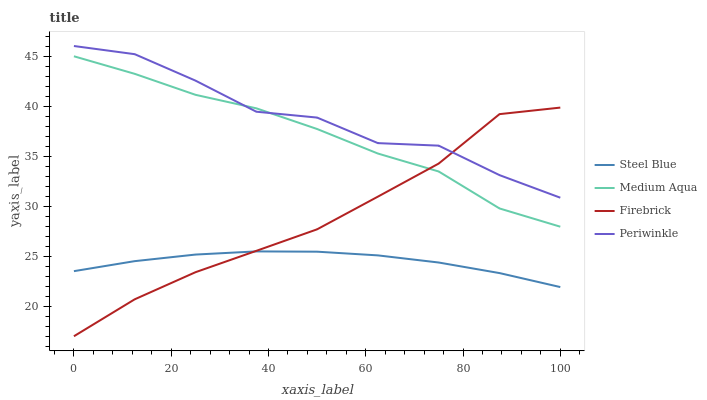Does Steel Blue have the minimum area under the curve?
Answer yes or no. Yes. Does Periwinkle have the maximum area under the curve?
Answer yes or no. Yes. Does Firebrick have the minimum area under the curve?
Answer yes or no. No. Does Firebrick have the maximum area under the curve?
Answer yes or no. No. Is Steel Blue the smoothest?
Answer yes or no. Yes. Is Periwinkle the roughest?
Answer yes or no. Yes. Is Firebrick the smoothest?
Answer yes or no. No. Is Firebrick the roughest?
Answer yes or no. No. Does Firebrick have the lowest value?
Answer yes or no. Yes. Does Medium Aqua have the lowest value?
Answer yes or no. No. Does Periwinkle have the highest value?
Answer yes or no. Yes. Does Firebrick have the highest value?
Answer yes or no. No. Is Steel Blue less than Medium Aqua?
Answer yes or no. Yes. Is Medium Aqua greater than Steel Blue?
Answer yes or no. Yes. Does Firebrick intersect Periwinkle?
Answer yes or no. Yes. Is Firebrick less than Periwinkle?
Answer yes or no. No. Is Firebrick greater than Periwinkle?
Answer yes or no. No. Does Steel Blue intersect Medium Aqua?
Answer yes or no. No. 